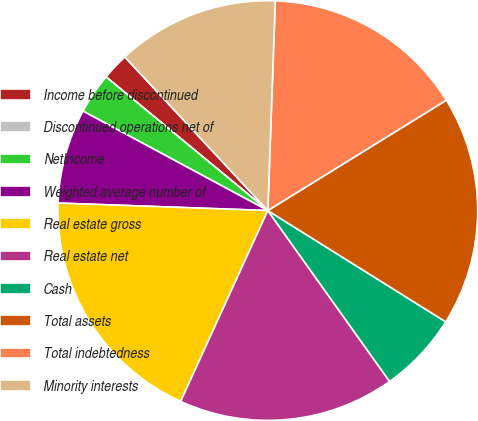Convert chart. <chart><loc_0><loc_0><loc_500><loc_500><pie_chart><fcel>Income before discontinued<fcel>Discontinued operations net of<fcel>NetIncome<fcel>Weighted average number of<fcel>Real estate gross<fcel>Real estate net<fcel>Cash<fcel>Total assets<fcel>Total indebtedness<fcel>Minority interests<nl><fcel>2.08%<fcel>0.0%<fcel>3.13%<fcel>7.29%<fcel>18.75%<fcel>16.67%<fcel>6.25%<fcel>17.71%<fcel>15.62%<fcel>12.5%<nl></chart> 